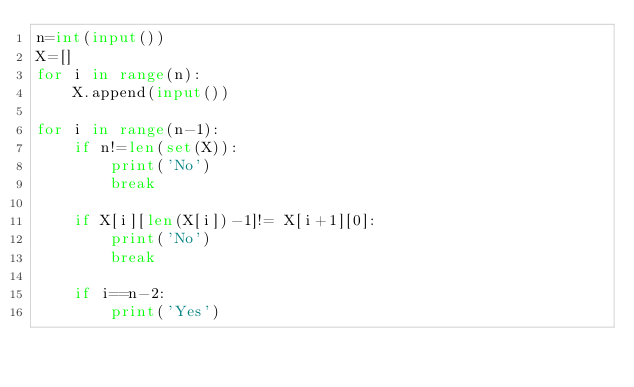Convert code to text. <code><loc_0><loc_0><loc_500><loc_500><_Python_>n=int(input())
X=[]
for i in range(n):
    X.append(input())
    
for i in range(n-1):
    if n!=len(set(X)):
        print('No')
        break
    
    if X[i][len(X[i])-1]!= X[i+1][0]:
        print('No')
        break
    
    if i==n-2:
        print('Yes')</code> 